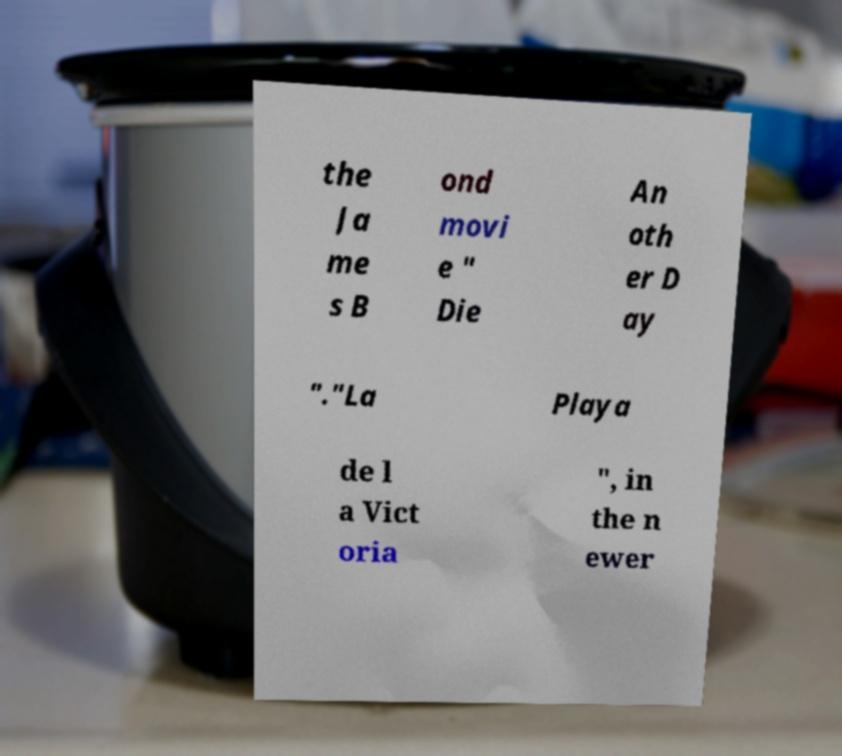I need the written content from this picture converted into text. Can you do that? the Ja me s B ond movi e " Die An oth er D ay "."La Playa de l a Vict oria ", in the n ewer 